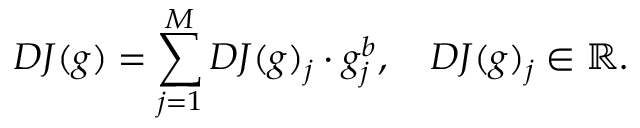<formula> <loc_0><loc_0><loc_500><loc_500>D J ( g ) = \sum _ { j = 1 } ^ { M } D J ( g ) _ { j } \cdot g _ { j } ^ { b } , \quad D J ( g ) _ { j } \in \mathbb { R } .</formula> 